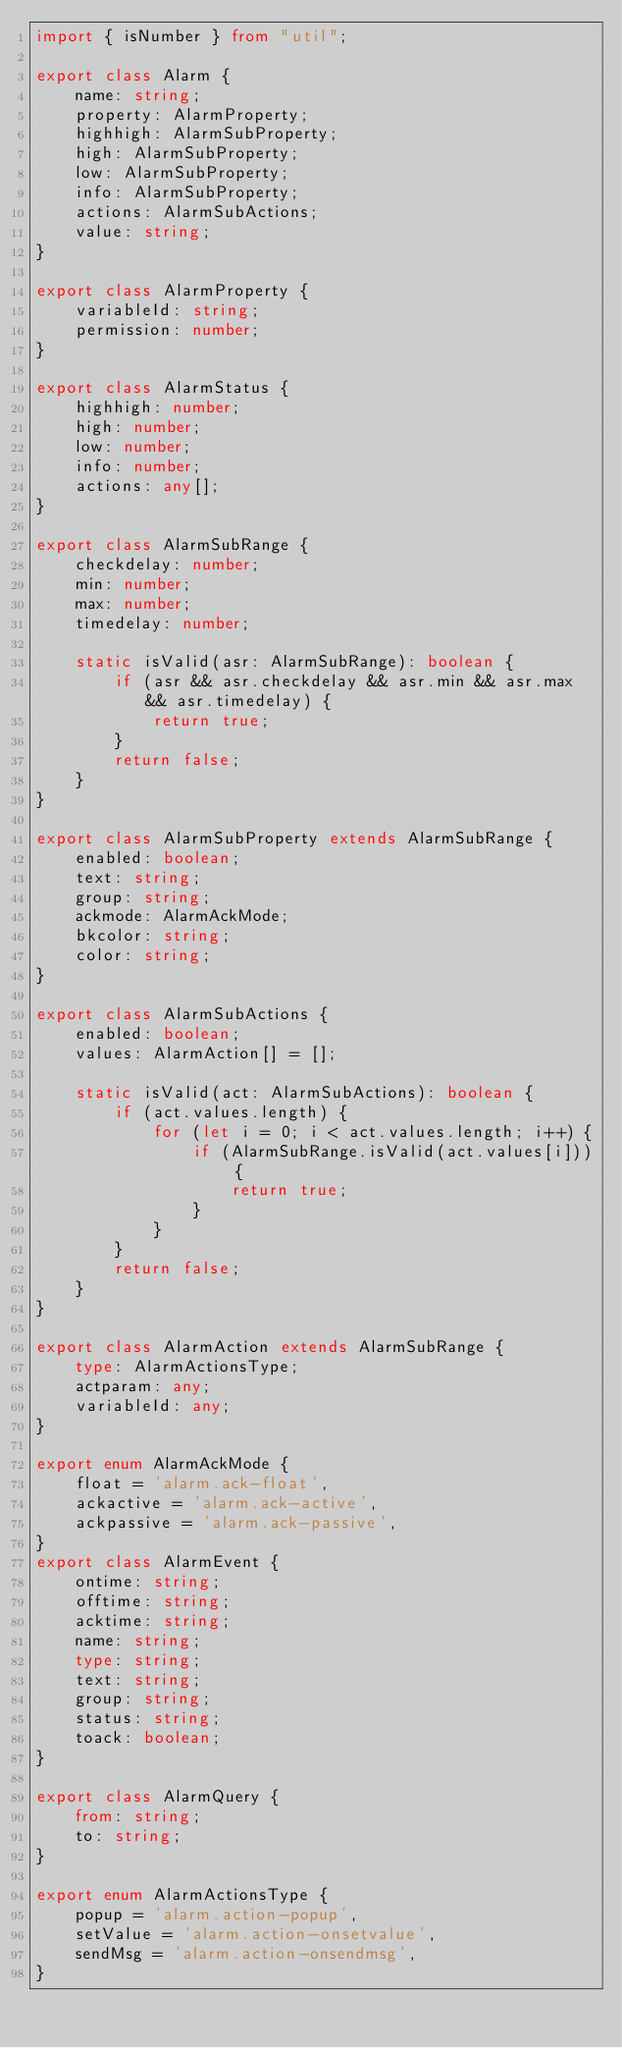Convert code to text. <code><loc_0><loc_0><loc_500><loc_500><_TypeScript_>import { isNumber } from "util";

export class Alarm {
    name: string;
    property: AlarmProperty;
    highhigh: AlarmSubProperty;
    high: AlarmSubProperty;
    low: AlarmSubProperty;
    info: AlarmSubProperty;
    actions: AlarmSubActions;
    value: string;
}

export class AlarmProperty {
    variableId: string;
    permission: number;
}

export class AlarmStatus { 
    highhigh: number;
    high: number;
    low: number;
    info: number;
    actions: any[];
}

export class AlarmSubRange {
    checkdelay: number;
    min: number;
    max: number;
    timedelay: number;
    
    static isValid(asr: AlarmSubRange): boolean {
        if (asr && asr.checkdelay && asr.min && asr.max && asr.timedelay) {
            return true;
        }
        return false;
    }
}

export class AlarmSubProperty extends AlarmSubRange {
    enabled: boolean;
    text: string;
    group: string;
    ackmode: AlarmAckMode;
    bkcolor: string;
    color: string;
}

export class AlarmSubActions {
    enabled: boolean;
    values: AlarmAction[] = [];

    static isValid(act: AlarmSubActions): boolean {
        if (act.values.length) {
            for (let i = 0; i < act.values.length; i++) {
                if (AlarmSubRange.isValid(act.values[i])) {
                    return true;
                }
            }
        }
        return false;
    }
}

export class AlarmAction extends AlarmSubRange {
    type: AlarmActionsType;
    actparam: any;
    variableId: any;
}

export enum AlarmAckMode {
    float = 'alarm.ack-float',
    ackactive = 'alarm.ack-active',
    ackpassive = 'alarm.ack-passive',
}
export class AlarmEvent {
    ontime: string;
    offtime: string;
    acktime: string;
    name: string;
    type: string;
    text: string;
    group: string;
    status: string;
    toack: boolean;
}

export class AlarmQuery {
    from: string;
    to: string;
}

export enum AlarmActionsType {
    popup = 'alarm.action-popup',
    setValue = 'alarm.action-onsetvalue',
    sendMsg = 'alarm.action-onsendmsg',
}</code> 